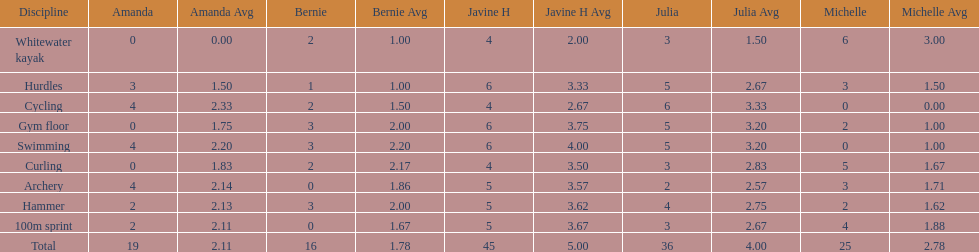Which discipline appears first on this chart? Whitewater kayak. 